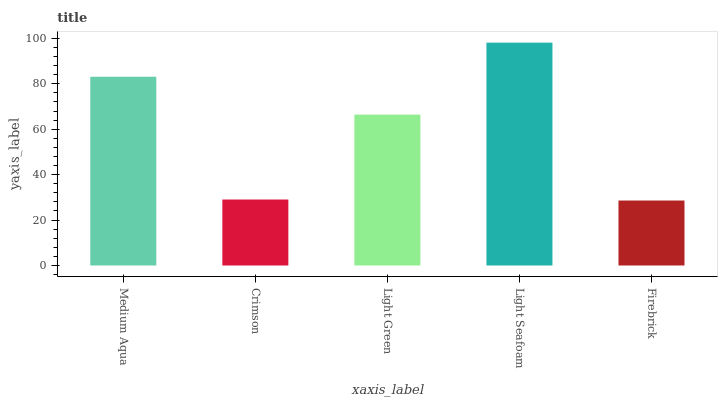Is Firebrick the minimum?
Answer yes or no. Yes. Is Light Seafoam the maximum?
Answer yes or no. Yes. Is Crimson the minimum?
Answer yes or no. No. Is Crimson the maximum?
Answer yes or no. No. Is Medium Aqua greater than Crimson?
Answer yes or no. Yes. Is Crimson less than Medium Aqua?
Answer yes or no. Yes. Is Crimson greater than Medium Aqua?
Answer yes or no. No. Is Medium Aqua less than Crimson?
Answer yes or no. No. Is Light Green the high median?
Answer yes or no. Yes. Is Light Green the low median?
Answer yes or no. Yes. Is Crimson the high median?
Answer yes or no. No. Is Medium Aqua the low median?
Answer yes or no. No. 